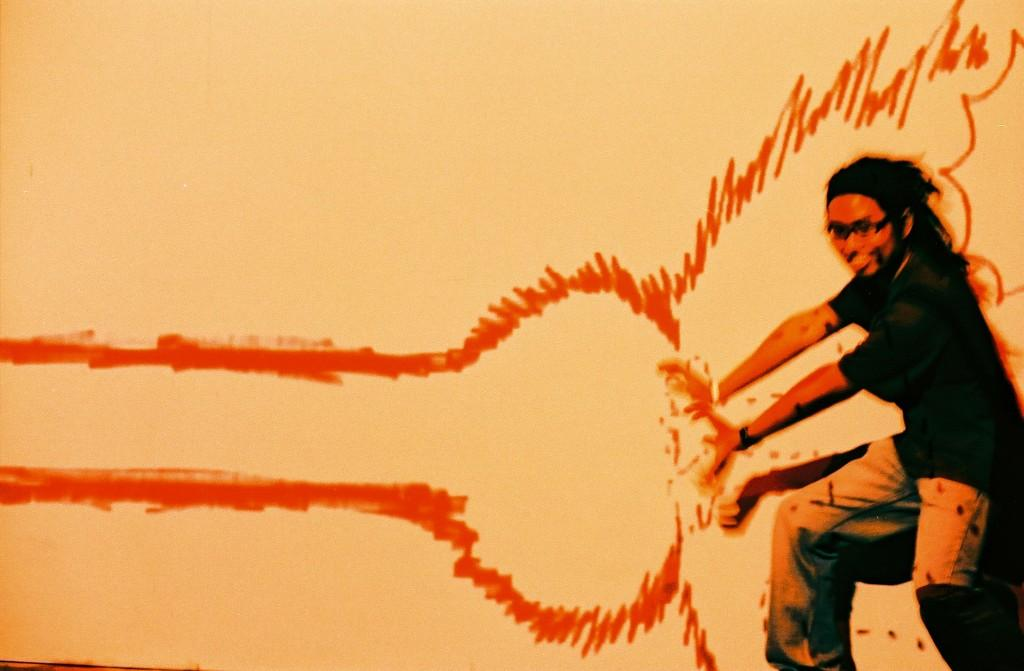What is depicted on the wall in the image? There is a painting on a wall in the image. Can you describe the person standing in the image? A person is standing on the right side of the image. What sound does the stream make in the image? There is no stream present in the image. How many times does the person cry in the image? There is no indication of the person crying in the image. 